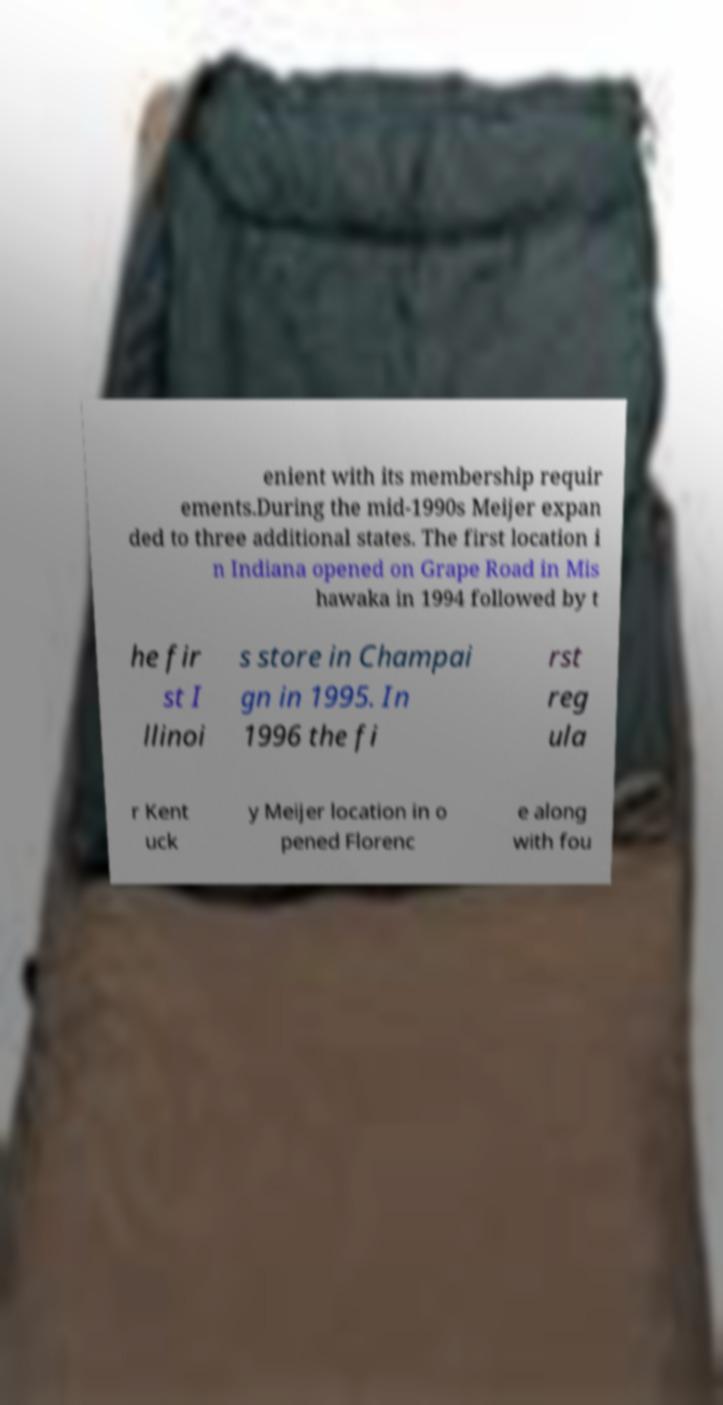Please read and relay the text visible in this image. What does it say? enient with its membership requir ements.During the mid-1990s Meijer expan ded to three additional states. The first location i n Indiana opened on Grape Road in Mis hawaka in 1994 followed by t he fir st I llinoi s store in Champai gn in 1995. In 1996 the fi rst reg ula r Kent uck y Meijer location in o pened Florenc e along with fou 